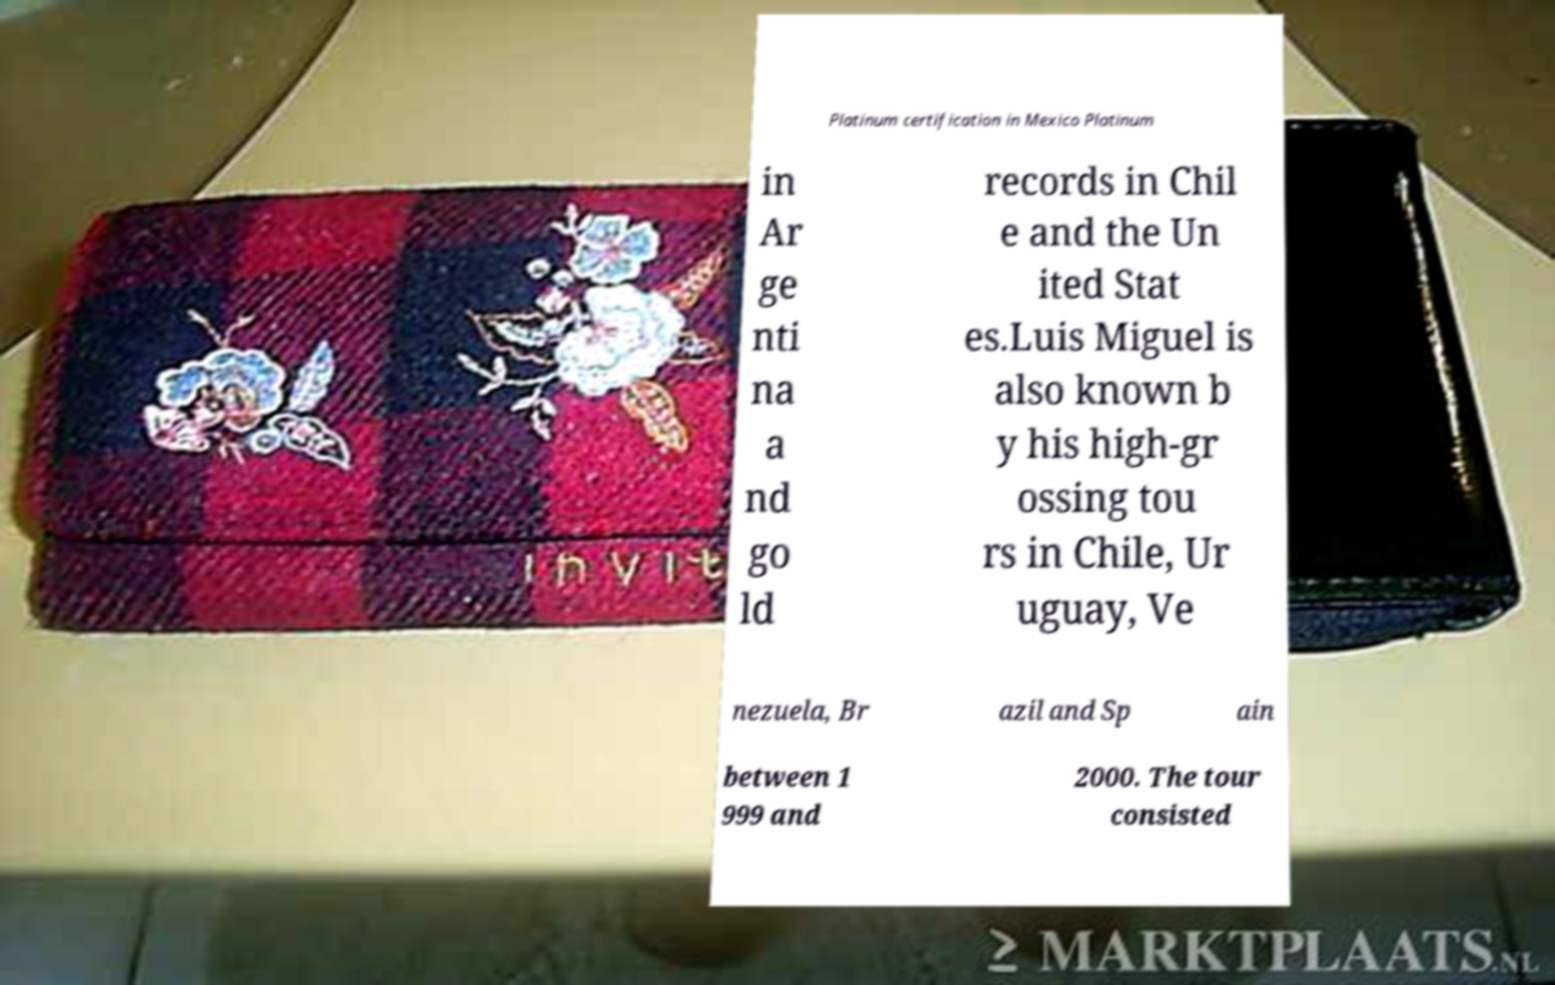There's text embedded in this image that I need extracted. Can you transcribe it verbatim? Platinum certification in Mexico Platinum in Ar ge nti na a nd go ld records in Chil e and the Un ited Stat es.Luis Miguel is also known b y his high-gr ossing tou rs in Chile, Ur uguay, Ve nezuela, Br azil and Sp ain between 1 999 and 2000. The tour consisted 